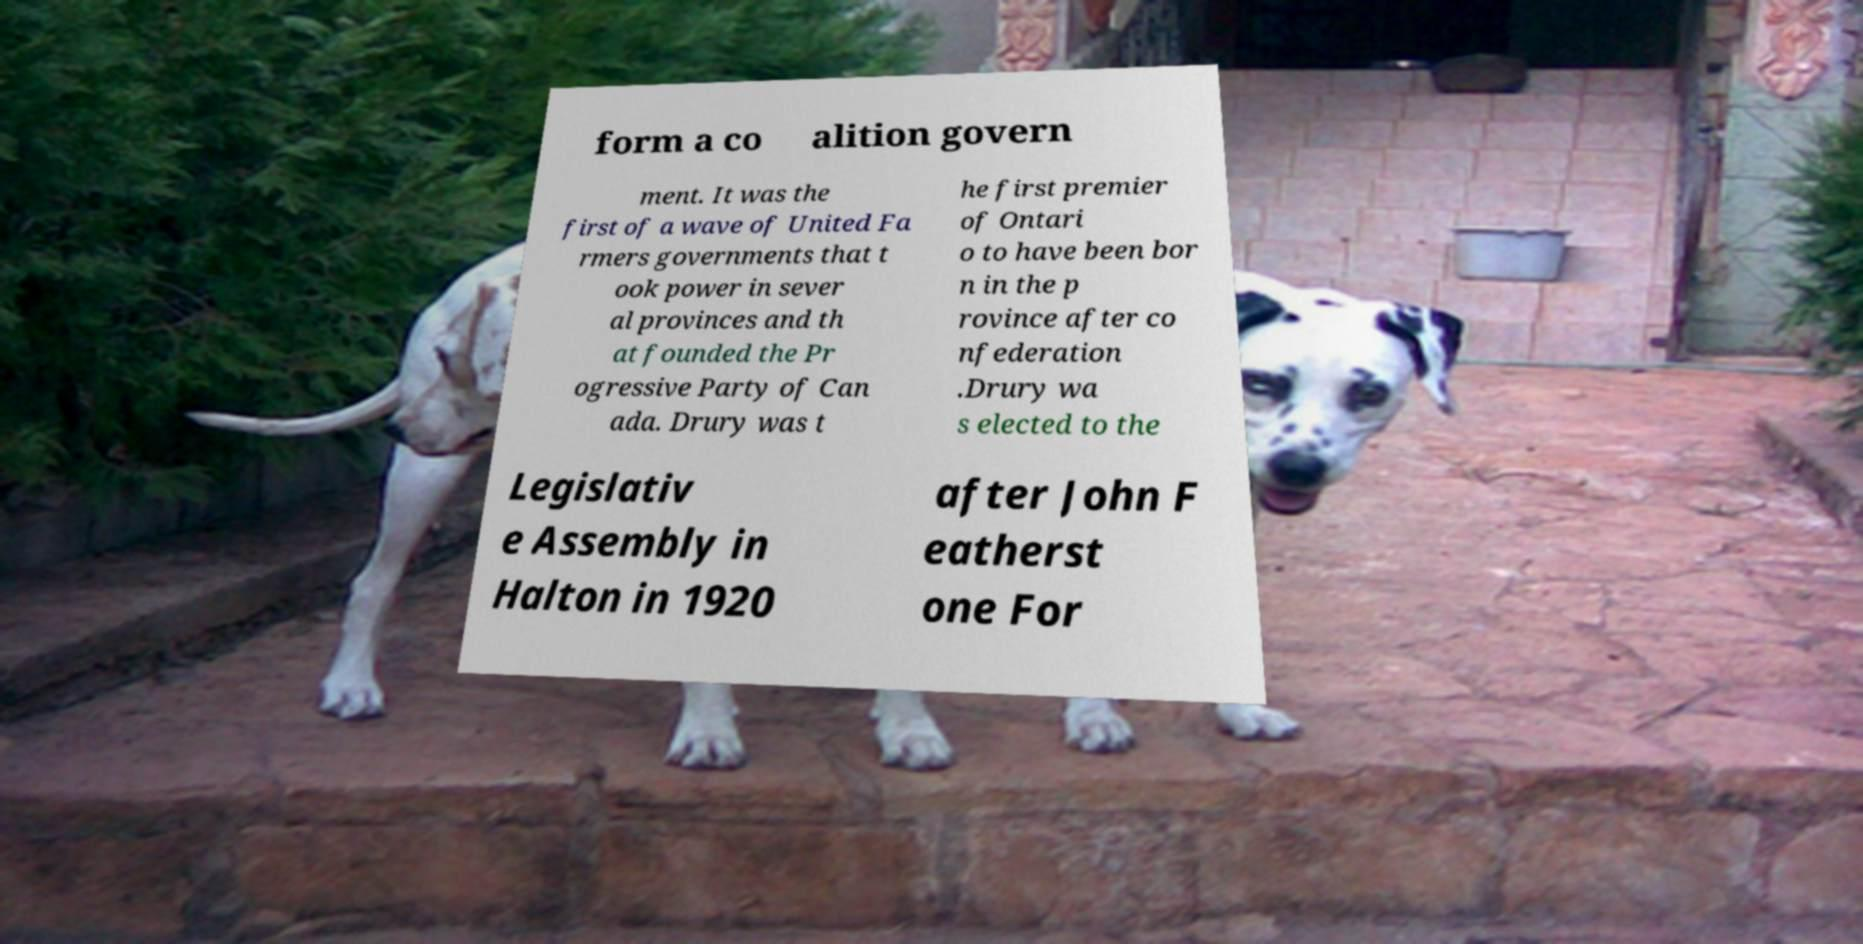Please read and relay the text visible in this image. What does it say? form a co alition govern ment. It was the first of a wave of United Fa rmers governments that t ook power in sever al provinces and th at founded the Pr ogressive Party of Can ada. Drury was t he first premier of Ontari o to have been bor n in the p rovince after co nfederation .Drury wa s elected to the Legislativ e Assembly in Halton in 1920 after John F eatherst one For 